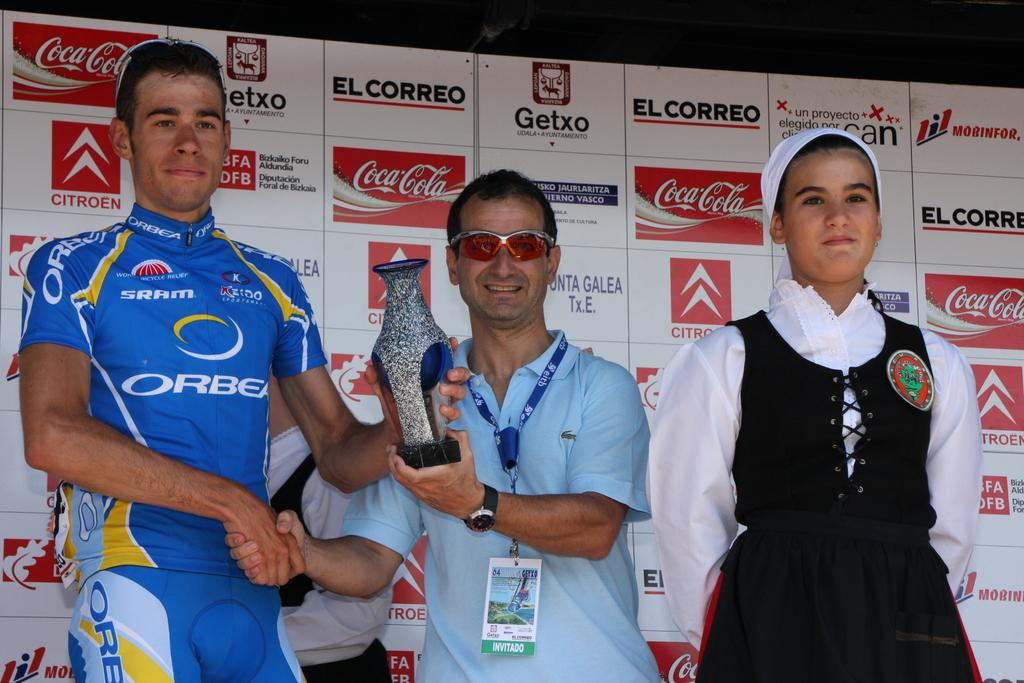<image>
Render a clear and concise summary of the photo. A big sponsor of the event is Coca-Cola 